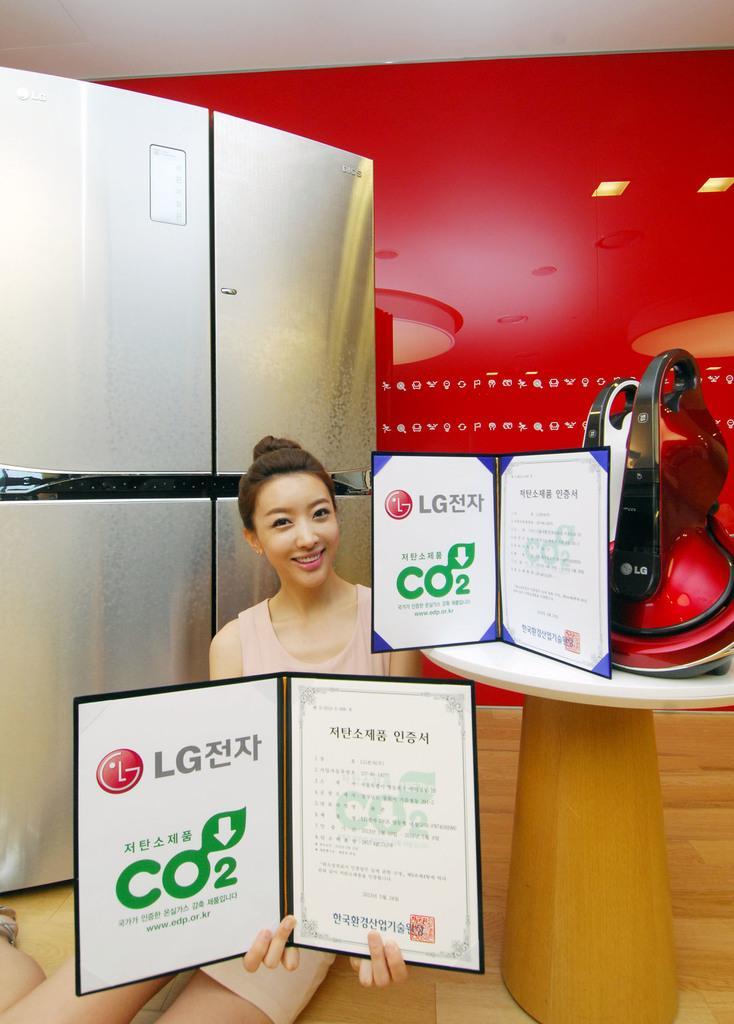Could you give a brief overview of what you see in this image? In this image, we can see a lady holding an object. We can see a table with some objects like a poster with some image and text. We can see the wall with some text. We can see a refrigerator. We can see the ground. We can see some lights. 